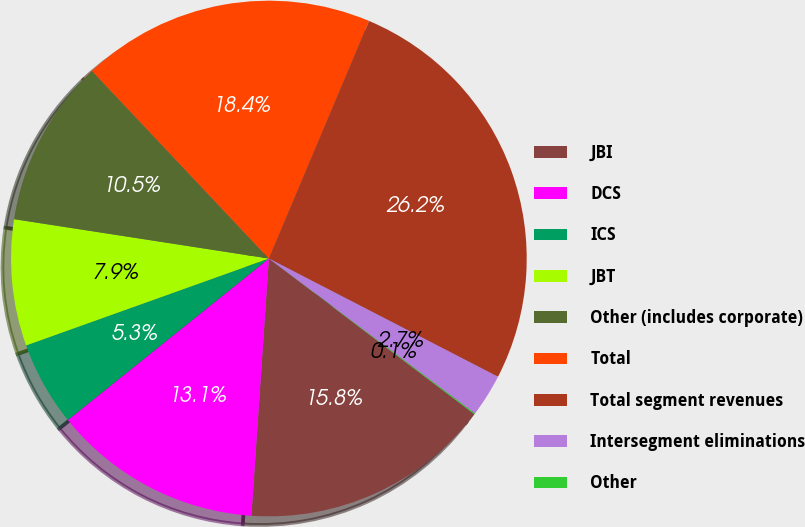<chart> <loc_0><loc_0><loc_500><loc_500><pie_chart><fcel>JBI<fcel>DCS<fcel>ICS<fcel>JBT<fcel>Other (includes corporate)<fcel>Total<fcel>Total segment revenues<fcel>Intersegment eliminations<fcel>Other<nl><fcel>15.76%<fcel>13.15%<fcel>5.3%<fcel>7.91%<fcel>10.53%<fcel>18.38%<fcel>26.23%<fcel>2.68%<fcel>0.06%<nl></chart> 